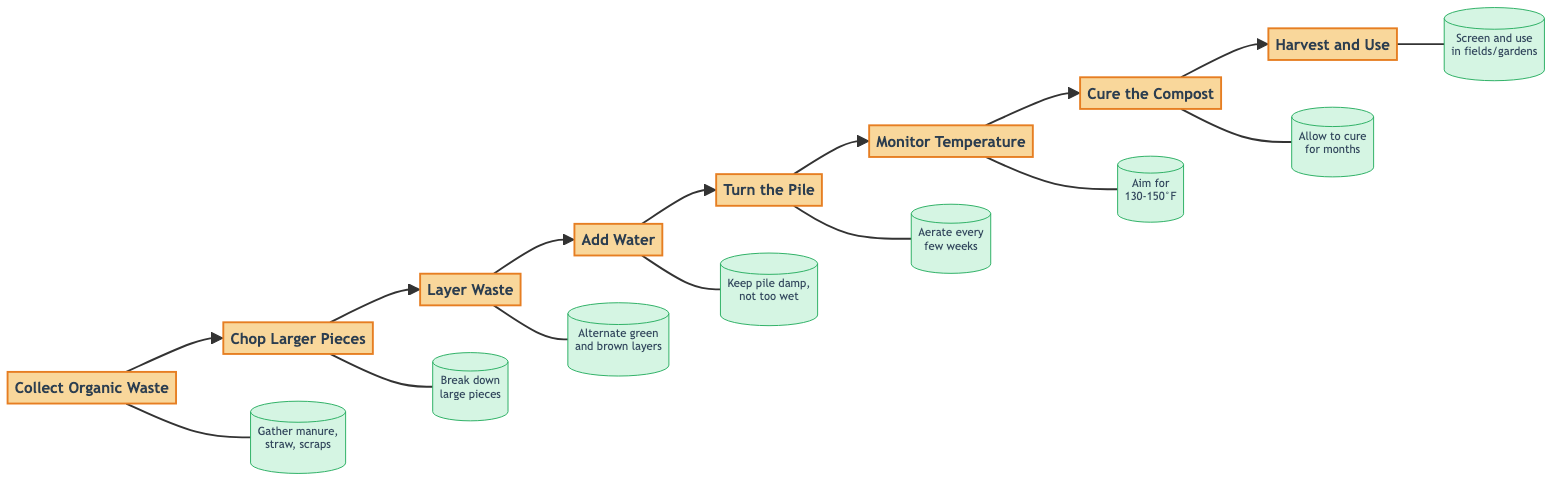What is the first step in the composting process? The diagram indicates that the first step is "Collect Organic Waste," making it the initial action needed in the composting process.
Answer: Collect Organic Waste How many steps are outlined in the composting process? By counting the nodes in the diagram, there are a total of eight steps presented in the composting process flowchart.
Answer: Eight steps What is added after layering the waste? According to the flowchart, after layering the waste, the next action is "Add Water," indicating the additional task required to maintain moisture in the pile.
Answer: Add Water What temperature should the compost reach to eliminate pathogens? The diagram specifies that the compost should ideally reach a temperature of "130-150°F" for effective treatment of pathogens and weed seeds, as outlined in the temperature monitoring step.
Answer: 130-150°F What do you do after turning the pile? From the flowchart, once the pile is turned, the following action is to "Monitor Temperature," indicating the importance of checking the heat levels thereafter.
Answer: Monitor Temperature How does the curing of compost contribute to its quality? The diagram shows that "Cure the Compost" is a crucial step that allows compost to enhance nutrient stability over a few months—a foundational knowledge point indicating time for improvement of its quality before use.
Answer: Enhancing nutrient stability Which two types of materials should be alternated when layering waste? The composting process advises the alternation of "green materials" (such as fresh manure and vegetable scraps) with "brown materials" (like straw and dried leaves) during the layering step, ensuring a balanced composting mix.
Answer: Green and brown materials What should you do with the compost after curing? After the compost has cured, the flowchart outlines the final step as "Harvest and Use," directing you to take the compost and apply it to enrich soil.
Answer: Harvest and Use 